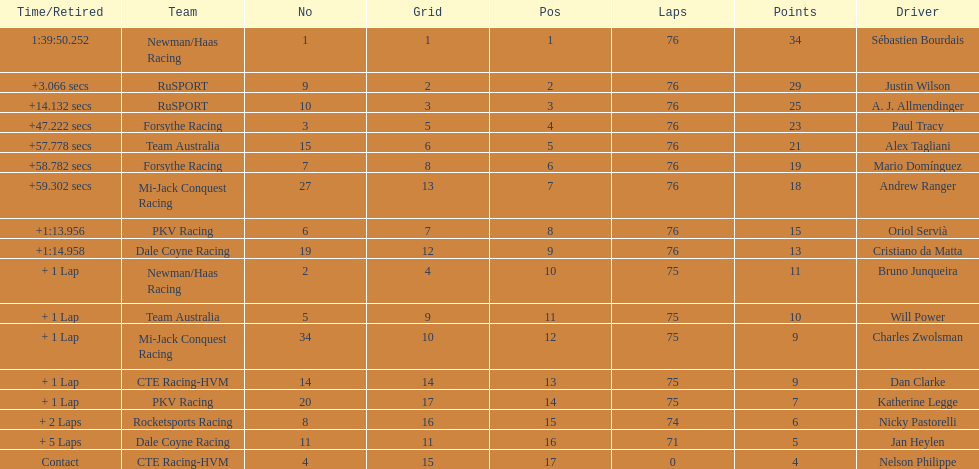Which driver earned the least amount of points. Nelson Philippe. 